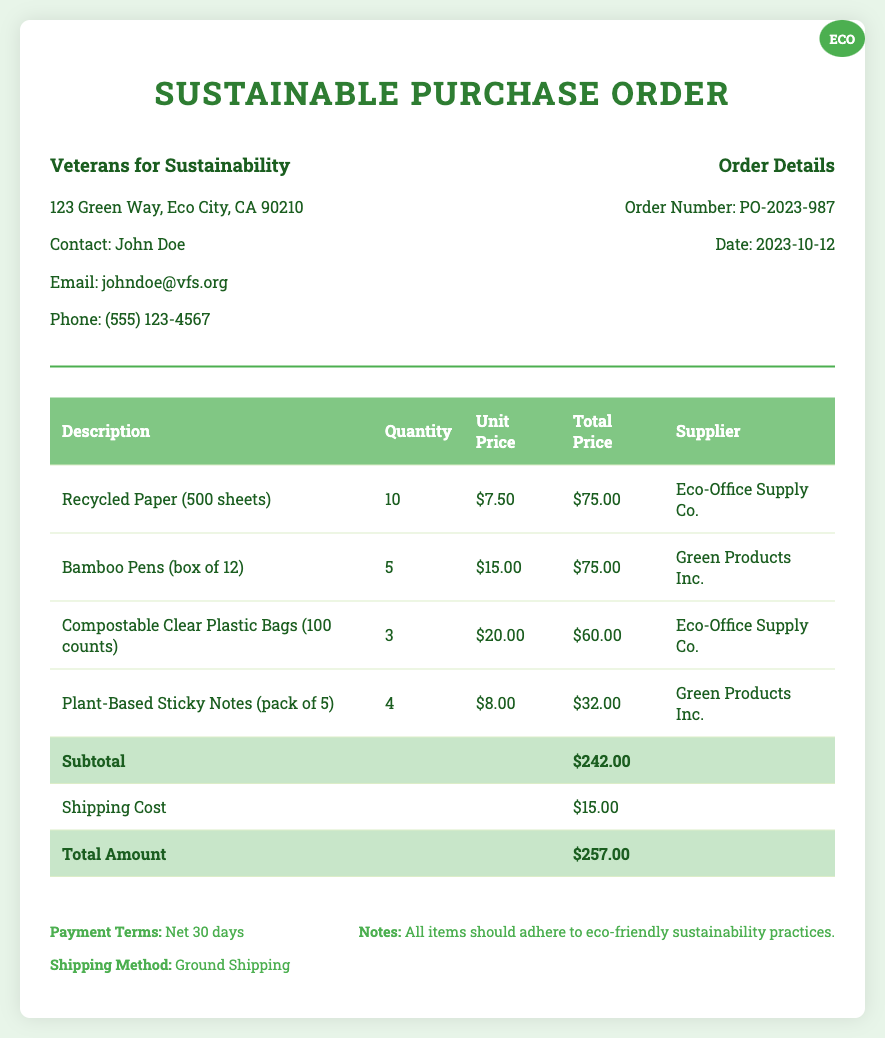What is the total amount? The total amount is found in the document summarizing the subtotal and shipping cost, which is $242.00 + $15.00.
Answer: $257.00 Who is the contact person for the buyer? The document lists John Doe as the contact person for Veterans for Sustainability.
Answer: John Doe What is the order number? The order number is mentioned under the order details in the document.
Answer: PO-2023-987 What is the shipping cost? The document specifies the shipping cost before calculating the total amount.
Answer: $15.00 What type of bags are included in the order? The document describes compostable clear plastic bags as one of the items ordered.
Answer: Compostable Clear Plastic Bags Which company supplies the bamboo pens? The supplier for the bamboo pens is stated in the document.
Answer: Green Products Inc What is the date of the order? The order date is clearly indicated in the order details section of the document.
Answer: 2023-10-12 How many recycled paper packs were ordered? The quantity of recycled paper packs ordered is specified in the document.
Answer: 10 What are the payment terms? Payment terms are specified at the bottom of the document.
Answer: Net 30 days 